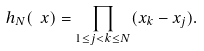Convert formula to latex. <formula><loc_0><loc_0><loc_500><loc_500>h _ { N } ( \ x ) = \prod _ { 1 \leq j < k \leq N } ( x _ { k } - x _ { j } ) .</formula> 